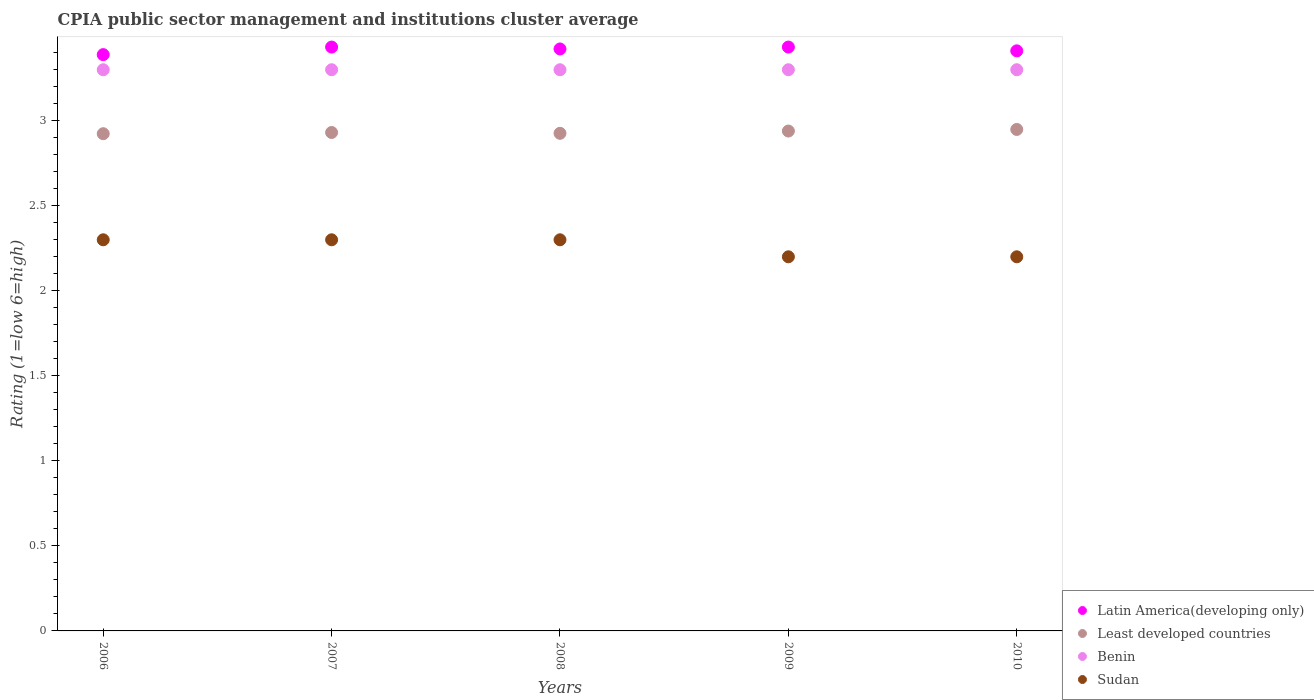What is the CPIA rating in Sudan in 2008?
Provide a short and direct response. 2.3. Across all years, what is the minimum CPIA rating in Benin?
Keep it short and to the point. 3.3. In which year was the CPIA rating in Benin maximum?
Provide a short and direct response. 2006. What is the total CPIA rating in Least developed countries in the graph?
Offer a very short reply. 14.67. What is the difference between the CPIA rating in Least developed countries in 2009 and the CPIA rating in Benin in 2007?
Give a very brief answer. -0.36. What is the average CPIA rating in Benin per year?
Make the answer very short. 3.3. In the year 2009, what is the difference between the CPIA rating in Benin and CPIA rating in Least developed countries?
Provide a short and direct response. 0.36. In how many years, is the CPIA rating in Sudan greater than 3.1?
Make the answer very short. 0. What is the ratio of the CPIA rating in Least developed countries in 2007 to that in 2008?
Your answer should be compact. 1. Is the difference between the CPIA rating in Benin in 2006 and 2007 greater than the difference between the CPIA rating in Least developed countries in 2006 and 2007?
Give a very brief answer. Yes. What is the difference between the highest and the second highest CPIA rating in Least developed countries?
Your response must be concise. 0.01. What is the difference between the highest and the lowest CPIA rating in Latin America(developing only)?
Keep it short and to the point. 0.04. Is it the case that in every year, the sum of the CPIA rating in Sudan and CPIA rating in Least developed countries  is greater than the sum of CPIA rating in Benin and CPIA rating in Latin America(developing only)?
Keep it short and to the point. No. Is it the case that in every year, the sum of the CPIA rating in Latin America(developing only) and CPIA rating in Benin  is greater than the CPIA rating in Sudan?
Ensure brevity in your answer.  Yes. Does the CPIA rating in Latin America(developing only) monotonically increase over the years?
Provide a succinct answer. No. Is the CPIA rating in Latin America(developing only) strictly greater than the CPIA rating in Least developed countries over the years?
Make the answer very short. Yes. How many dotlines are there?
Your answer should be very brief. 4. What is the difference between two consecutive major ticks on the Y-axis?
Give a very brief answer. 0.5. Does the graph contain any zero values?
Ensure brevity in your answer.  No. How are the legend labels stacked?
Offer a very short reply. Vertical. What is the title of the graph?
Your response must be concise. CPIA public sector management and institutions cluster average. Does "Serbia" appear as one of the legend labels in the graph?
Keep it short and to the point. No. What is the Rating (1=low 6=high) in Latin America(developing only) in 2006?
Provide a succinct answer. 3.39. What is the Rating (1=low 6=high) of Least developed countries in 2006?
Provide a succinct answer. 2.92. What is the Rating (1=low 6=high) in Latin America(developing only) in 2007?
Offer a very short reply. 3.43. What is the Rating (1=low 6=high) of Least developed countries in 2007?
Your answer should be very brief. 2.93. What is the Rating (1=low 6=high) in Benin in 2007?
Make the answer very short. 3.3. What is the Rating (1=low 6=high) of Latin America(developing only) in 2008?
Your answer should be very brief. 3.42. What is the Rating (1=low 6=high) in Least developed countries in 2008?
Provide a succinct answer. 2.93. What is the Rating (1=low 6=high) in Sudan in 2008?
Provide a short and direct response. 2.3. What is the Rating (1=low 6=high) of Latin America(developing only) in 2009?
Provide a short and direct response. 3.43. What is the Rating (1=low 6=high) in Least developed countries in 2009?
Offer a terse response. 2.94. What is the Rating (1=low 6=high) of Latin America(developing only) in 2010?
Your response must be concise. 3.41. What is the Rating (1=low 6=high) of Least developed countries in 2010?
Give a very brief answer. 2.95. Across all years, what is the maximum Rating (1=low 6=high) in Latin America(developing only)?
Make the answer very short. 3.43. Across all years, what is the maximum Rating (1=low 6=high) of Least developed countries?
Keep it short and to the point. 2.95. Across all years, what is the maximum Rating (1=low 6=high) of Benin?
Your answer should be compact. 3.3. Across all years, what is the maximum Rating (1=low 6=high) of Sudan?
Provide a succinct answer. 2.3. Across all years, what is the minimum Rating (1=low 6=high) of Latin America(developing only)?
Keep it short and to the point. 3.39. Across all years, what is the minimum Rating (1=low 6=high) in Least developed countries?
Keep it short and to the point. 2.92. Across all years, what is the minimum Rating (1=low 6=high) in Benin?
Provide a short and direct response. 3.3. Across all years, what is the minimum Rating (1=low 6=high) of Sudan?
Offer a very short reply. 2.2. What is the total Rating (1=low 6=high) in Latin America(developing only) in the graph?
Give a very brief answer. 17.09. What is the total Rating (1=low 6=high) of Least developed countries in the graph?
Keep it short and to the point. 14.67. What is the difference between the Rating (1=low 6=high) of Latin America(developing only) in 2006 and that in 2007?
Your response must be concise. -0.04. What is the difference between the Rating (1=low 6=high) of Least developed countries in 2006 and that in 2007?
Provide a succinct answer. -0.01. What is the difference between the Rating (1=low 6=high) of Sudan in 2006 and that in 2007?
Offer a very short reply. 0. What is the difference between the Rating (1=low 6=high) in Latin America(developing only) in 2006 and that in 2008?
Provide a short and direct response. -0.03. What is the difference between the Rating (1=low 6=high) of Least developed countries in 2006 and that in 2008?
Your answer should be very brief. -0. What is the difference between the Rating (1=low 6=high) in Sudan in 2006 and that in 2008?
Keep it short and to the point. 0. What is the difference between the Rating (1=low 6=high) in Latin America(developing only) in 2006 and that in 2009?
Your answer should be very brief. -0.04. What is the difference between the Rating (1=low 6=high) in Least developed countries in 2006 and that in 2009?
Offer a terse response. -0.02. What is the difference between the Rating (1=low 6=high) in Benin in 2006 and that in 2009?
Your answer should be very brief. 0. What is the difference between the Rating (1=low 6=high) in Latin America(developing only) in 2006 and that in 2010?
Provide a succinct answer. -0.02. What is the difference between the Rating (1=low 6=high) in Least developed countries in 2006 and that in 2010?
Your response must be concise. -0.03. What is the difference between the Rating (1=low 6=high) of Benin in 2006 and that in 2010?
Your answer should be very brief. 0. What is the difference between the Rating (1=low 6=high) of Latin America(developing only) in 2007 and that in 2008?
Provide a short and direct response. 0.01. What is the difference between the Rating (1=low 6=high) of Least developed countries in 2007 and that in 2008?
Offer a terse response. 0. What is the difference between the Rating (1=low 6=high) in Least developed countries in 2007 and that in 2009?
Give a very brief answer. -0.01. What is the difference between the Rating (1=low 6=high) in Benin in 2007 and that in 2009?
Your answer should be compact. 0. What is the difference between the Rating (1=low 6=high) of Sudan in 2007 and that in 2009?
Keep it short and to the point. 0.1. What is the difference between the Rating (1=low 6=high) of Latin America(developing only) in 2007 and that in 2010?
Ensure brevity in your answer.  0.02. What is the difference between the Rating (1=low 6=high) of Least developed countries in 2007 and that in 2010?
Offer a terse response. -0.02. What is the difference between the Rating (1=low 6=high) of Latin America(developing only) in 2008 and that in 2009?
Your answer should be very brief. -0.01. What is the difference between the Rating (1=low 6=high) of Least developed countries in 2008 and that in 2009?
Give a very brief answer. -0.01. What is the difference between the Rating (1=low 6=high) of Benin in 2008 and that in 2009?
Your response must be concise. 0. What is the difference between the Rating (1=low 6=high) in Sudan in 2008 and that in 2009?
Give a very brief answer. 0.1. What is the difference between the Rating (1=low 6=high) in Latin America(developing only) in 2008 and that in 2010?
Offer a very short reply. 0.01. What is the difference between the Rating (1=low 6=high) of Least developed countries in 2008 and that in 2010?
Your response must be concise. -0.02. What is the difference between the Rating (1=low 6=high) in Latin America(developing only) in 2009 and that in 2010?
Offer a terse response. 0.02. What is the difference between the Rating (1=low 6=high) of Least developed countries in 2009 and that in 2010?
Ensure brevity in your answer.  -0.01. What is the difference between the Rating (1=low 6=high) in Latin America(developing only) in 2006 and the Rating (1=low 6=high) in Least developed countries in 2007?
Your response must be concise. 0.46. What is the difference between the Rating (1=low 6=high) of Latin America(developing only) in 2006 and the Rating (1=low 6=high) of Benin in 2007?
Offer a terse response. 0.09. What is the difference between the Rating (1=low 6=high) in Latin America(developing only) in 2006 and the Rating (1=low 6=high) in Sudan in 2007?
Provide a succinct answer. 1.09. What is the difference between the Rating (1=low 6=high) in Least developed countries in 2006 and the Rating (1=low 6=high) in Benin in 2007?
Ensure brevity in your answer.  -0.38. What is the difference between the Rating (1=low 6=high) in Least developed countries in 2006 and the Rating (1=low 6=high) in Sudan in 2007?
Make the answer very short. 0.62. What is the difference between the Rating (1=low 6=high) of Latin America(developing only) in 2006 and the Rating (1=low 6=high) of Least developed countries in 2008?
Provide a short and direct response. 0.46. What is the difference between the Rating (1=low 6=high) of Latin America(developing only) in 2006 and the Rating (1=low 6=high) of Benin in 2008?
Offer a terse response. 0.09. What is the difference between the Rating (1=low 6=high) in Latin America(developing only) in 2006 and the Rating (1=low 6=high) in Sudan in 2008?
Ensure brevity in your answer.  1.09. What is the difference between the Rating (1=low 6=high) of Least developed countries in 2006 and the Rating (1=low 6=high) of Benin in 2008?
Offer a very short reply. -0.38. What is the difference between the Rating (1=low 6=high) of Least developed countries in 2006 and the Rating (1=low 6=high) of Sudan in 2008?
Ensure brevity in your answer.  0.62. What is the difference between the Rating (1=low 6=high) of Benin in 2006 and the Rating (1=low 6=high) of Sudan in 2008?
Your answer should be very brief. 1. What is the difference between the Rating (1=low 6=high) of Latin America(developing only) in 2006 and the Rating (1=low 6=high) of Least developed countries in 2009?
Give a very brief answer. 0.45. What is the difference between the Rating (1=low 6=high) of Latin America(developing only) in 2006 and the Rating (1=low 6=high) of Benin in 2009?
Your response must be concise. 0.09. What is the difference between the Rating (1=low 6=high) of Latin America(developing only) in 2006 and the Rating (1=low 6=high) of Sudan in 2009?
Ensure brevity in your answer.  1.19. What is the difference between the Rating (1=low 6=high) of Least developed countries in 2006 and the Rating (1=low 6=high) of Benin in 2009?
Offer a very short reply. -0.38. What is the difference between the Rating (1=low 6=high) of Least developed countries in 2006 and the Rating (1=low 6=high) of Sudan in 2009?
Your answer should be very brief. 0.72. What is the difference between the Rating (1=low 6=high) in Benin in 2006 and the Rating (1=low 6=high) in Sudan in 2009?
Give a very brief answer. 1.1. What is the difference between the Rating (1=low 6=high) in Latin America(developing only) in 2006 and the Rating (1=low 6=high) in Least developed countries in 2010?
Provide a succinct answer. 0.44. What is the difference between the Rating (1=low 6=high) in Latin America(developing only) in 2006 and the Rating (1=low 6=high) in Benin in 2010?
Your answer should be compact. 0.09. What is the difference between the Rating (1=low 6=high) in Latin America(developing only) in 2006 and the Rating (1=low 6=high) in Sudan in 2010?
Your answer should be compact. 1.19. What is the difference between the Rating (1=low 6=high) in Least developed countries in 2006 and the Rating (1=low 6=high) in Benin in 2010?
Provide a short and direct response. -0.38. What is the difference between the Rating (1=low 6=high) in Least developed countries in 2006 and the Rating (1=low 6=high) in Sudan in 2010?
Offer a very short reply. 0.72. What is the difference between the Rating (1=low 6=high) in Benin in 2006 and the Rating (1=low 6=high) in Sudan in 2010?
Make the answer very short. 1.1. What is the difference between the Rating (1=low 6=high) of Latin America(developing only) in 2007 and the Rating (1=low 6=high) of Least developed countries in 2008?
Offer a terse response. 0.51. What is the difference between the Rating (1=low 6=high) in Latin America(developing only) in 2007 and the Rating (1=low 6=high) in Benin in 2008?
Keep it short and to the point. 0.13. What is the difference between the Rating (1=low 6=high) of Latin America(developing only) in 2007 and the Rating (1=low 6=high) of Sudan in 2008?
Give a very brief answer. 1.13. What is the difference between the Rating (1=low 6=high) of Least developed countries in 2007 and the Rating (1=low 6=high) of Benin in 2008?
Make the answer very short. -0.37. What is the difference between the Rating (1=low 6=high) in Least developed countries in 2007 and the Rating (1=low 6=high) in Sudan in 2008?
Your response must be concise. 0.63. What is the difference between the Rating (1=low 6=high) of Latin America(developing only) in 2007 and the Rating (1=low 6=high) of Least developed countries in 2009?
Your response must be concise. 0.49. What is the difference between the Rating (1=low 6=high) in Latin America(developing only) in 2007 and the Rating (1=low 6=high) in Benin in 2009?
Your answer should be very brief. 0.13. What is the difference between the Rating (1=low 6=high) in Latin America(developing only) in 2007 and the Rating (1=low 6=high) in Sudan in 2009?
Give a very brief answer. 1.23. What is the difference between the Rating (1=low 6=high) in Least developed countries in 2007 and the Rating (1=low 6=high) in Benin in 2009?
Your answer should be compact. -0.37. What is the difference between the Rating (1=low 6=high) of Least developed countries in 2007 and the Rating (1=low 6=high) of Sudan in 2009?
Your answer should be compact. 0.73. What is the difference between the Rating (1=low 6=high) in Latin America(developing only) in 2007 and the Rating (1=low 6=high) in Least developed countries in 2010?
Offer a terse response. 0.48. What is the difference between the Rating (1=low 6=high) in Latin America(developing only) in 2007 and the Rating (1=low 6=high) in Benin in 2010?
Your answer should be compact. 0.13. What is the difference between the Rating (1=low 6=high) in Latin America(developing only) in 2007 and the Rating (1=low 6=high) in Sudan in 2010?
Provide a short and direct response. 1.23. What is the difference between the Rating (1=low 6=high) in Least developed countries in 2007 and the Rating (1=low 6=high) in Benin in 2010?
Your response must be concise. -0.37. What is the difference between the Rating (1=low 6=high) in Least developed countries in 2007 and the Rating (1=low 6=high) in Sudan in 2010?
Offer a very short reply. 0.73. What is the difference between the Rating (1=low 6=high) of Latin America(developing only) in 2008 and the Rating (1=low 6=high) of Least developed countries in 2009?
Provide a succinct answer. 0.48. What is the difference between the Rating (1=low 6=high) of Latin America(developing only) in 2008 and the Rating (1=low 6=high) of Benin in 2009?
Offer a very short reply. 0.12. What is the difference between the Rating (1=low 6=high) in Latin America(developing only) in 2008 and the Rating (1=low 6=high) in Sudan in 2009?
Your answer should be compact. 1.22. What is the difference between the Rating (1=low 6=high) in Least developed countries in 2008 and the Rating (1=low 6=high) in Benin in 2009?
Your response must be concise. -0.37. What is the difference between the Rating (1=low 6=high) of Least developed countries in 2008 and the Rating (1=low 6=high) of Sudan in 2009?
Provide a succinct answer. 0.73. What is the difference between the Rating (1=low 6=high) of Benin in 2008 and the Rating (1=low 6=high) of Sudan in 2009?
Ensure brevity in your answer.  1.1. What is the difference between the Rating (1=low 6=high) of Latin America(developing only) in 2008 and the Rating (1=low 6=high) of Least developed countries in 2010?
Offer a very short reply. 0.47. What is the difference between the Rating (1=low 6=high) of Latin America(developing only) in 2008 and the Rating (1=low 6=high) of Benin in 2010?
Give a very brief answer. 0.12. What is the difference between the Rating (1=low 6=high) of Latin America(developing only) in 2008 and the Rating (1=low 6=high) of Sudan in 2010?
Give a very brief answer. 1.22. What is the difference between the Rating (1=low 6=high) in Least developed countries in 2008 and the Rating (1=low 6=high) in Benin in 2010?
Offer a very short reply. -0.37. What is the difference between the Rating (1=low 6=high) of Least developed countries in 2008 and the Rating (1=low 6=high) of Sudan in 2010?
Your answer should be compact. 0.73. What is the difference between the Rating (1=low 6=high) in Benin in 2008 and the Rating (1=low 6=high) in Sudan in 2010?
Your response must be concise. 1.1. What is the difference between the Rating (1=low 6=high) in Latin America(developing only) in 2009 and the Rating (1=low 6=high) in Least developed countries in 2010?
Offer a very short reply. 0.48. What is the difference between the Rating (1=low 6=high) of Latin America(developing only) in 2009 and the Rating (1=low 6=high) of Benin in 2010?
Offer a terse response. 0.13. What is the difference between the Rating (1=low 6=high) in Latin America(developing only) in 2009 and the Rating (1=low 6=high) in Sudan in 2010?
Your answer should be compact. 1.23. What is the difference between the Rating (1=low 6=high) in Least developed countries in 2009 and the Rating (1=low 6=high) in Benin in 2010?
Give a very brief answer. -0.36. What is the difference between the Rating (1=low 6=high) of Least developed countries in 2009 and the Rating (1=low 6=high) of Sudan in 2010?
Provide a short and direct response. 0.74. What is the difference between the Rating (1=low 6=high) of Benin in 2009 and the Rating (1=low 6=high) of Sudan in 2010?
Make the answer very short. 1.1. What is the average Rating (1=low 6=high) of Latin America(developing only) per year?
Offer a very short reply. 3.42. What is the average Rating (1=low 6=high) of Least developed countries per year?
Your answer should be compact. 2.93. What is the average Rating (1=low 6=high) in Benin per year?
Give a very brief answer. 3.3. What is the average Rating (1=low 6=high) in Sudan per year?
Your response must be concise. 2.26. In the year 2006, what is the difference between the Rating (1=low 6=high) of Latin America(developing only) and Rating (1=low 6=high) of Least developed countries?
Your response must be concise. 0.47. In the year 2006, what is the difference between the Rating (1=low 6=high) of Latin America(developing only) and Rating (1=low 6=high) of Benin?
Keep it short and to the point. 0.09. In the year 2006, what is the difference between the Rating (1=low 6=high) in Latin America(developing only) and Rating (1=low 6=high) in Sudan?
Offer a very short reply. 1.09. In the year 2006, what is the difference between the Rating (1=low 6=high) in Least developed countries and Rating (1=low 6=high) in Benin?
Provide a short and direct response. -0.38. In the year 2006, what is the difference between the Rating (1=low 6=high) of Least developed countries and Rating (1=low 6=high) of Sudan?
Ensure brevity in your answer.  0.62. In the year 2006, what is the difference between the Rating (1=low 6=high) in Benin and Rating (1=low 6=high) in Sudan?
Make the answer very short. 1. In the year 2007, what is the difference between the Rating (1=low 6=high) of Latin America(developing only) and Rating (1=low 6=high) of Least developed countries?
Make the answer very short. 0.5. In the year 2007, what is the difference between the Rating (1=low 6=high) of Latin America(developing only) and Rating (1=low 6=high) of Benin?
Provide a short and direct response. 0.13. In the year 2007, what is the difference between the Rating (1=low 6=high) of Latin America(developing only) and Rating (1=low 6=high) of Sudan?
Offer a terse response. 1.13. In the year 2007, what is the difference between the Rating (1=low 6=high) of Least developed countries and Rating (1=low 6=high) of Benin?
Ensure brevity in your answer.  -0.37. In the year 2007, what is the difference between the Rating (1=low 6=high) of Least developed countries and Rating (1=low 6=high) of Sudan?
Your answer should be very brief. 0.63. In the year 2007, what is the difference between the Rating (1=low 6=high) of Benin and Rating (1=low 6=high) of Sudan?
Ensure brevity in your answer.  1. In the year 2008, what is the difference between the Rating (1=low 6=high) in Latin America(developing only) and Rating (1=low 6=high) in Least developed countries?
Give a very brief answer. 0.5. In the year 2008, what is the difference between the Rating (1=low 6=high) of Latin America(developing only) and Rating (1=low 6=high) of Benin?
Your answer should be very brief. 0.12. In the year 2008, what is the difference between the Rating (1=low 6=high) in Latin America(developing only) and Rating (1=low 6=high) in Sudan?
Offer a terse response. 1.12. In the year 2008, what is the difference between the Rating (1=low 6=high) in Least developed countries and Rating (1=low 6=high) in Benin?
Give a very brief answer. -0.37. In the year 2008, what is the difference between the Rating (1=low 6=high) in Least developed countries and Rating (1=low 6=high) in Sudan?
Offer a terse response. 0.63. In the year 2008, what is the difference between the Rating (1=low 6=high) in Benin and Rating (1=low 6=high) in Sudan?
Offer a terse response. 1. In the year 2009, what is the difference between the Rating (1=low 6=high) in Latin America(developing only) and Rating (1=low 6=high) in Least developed countries?
Your answer should be very brief. 0.49. In the year 2009, what is the difference between the Rating (1=low 6=high) of Latin America(developing only) and Rating (1=low 6=high) of Benin?
Your answer should be compact. 0.13. In the year 2009, what is the difference between the Rating (1=low 6=high) of Latin America(developing only) and Rating (1=low 6=high) of Sudan?
Offer a very short reply. 1.23. In the year 2009, what is the difference between the Rating (1=low 6=high) in Least developed countries and Rating (1=low 6=high) in Benin?
Provide a succinct answer. -0.36. In the year 2009, what is the difference between the Rating (1=low 6=high) of Least developed countries and Rating (1=low 6=high) of Sudan?
Your answer should be compact. 0.74. In the year 2010, what is the difference between the Rating (1=low 6=high) in Latin America(developing only) and Rating (1=low 6=high) in Least developed countries?
Give a very brief answer. 0.46. In the year 2010, what is the difference between the Rating (1=low 6=high) in Latin America(developing only) and Rating (1=low 6=high) in Benin?
Offer a very short reply. 0.11. In the year 2010, what is the difference between the Rating (1=low 6=high) of Latin America(developing only) and Rating (1=low 6=high) of Sudan?
Offer a very short reply. 1.21. In the year 2010, what is the difference between the Rating (1=low 6=high) in Least developed countries and Rating (1=low 6=high) in Benin?
Make the answer very short. -0.35. In the year 2010, what is the difference between the Rating (1=low 6=high) in Least developed countries and Rating (1=low 6=high) in Sudan?
Offer a very short reply. 0.75. In the year 2010, what is the difference between the Rating (1=low 6=high) of Benin and Rating (1=low 6=high) of Sudan?
Provide a short and direct response. 1.1. What is the ratio of the Rating (1=low 6=high) in Latin America(developing only) in 2006 to that in 2007?
Provide a short and direct response. 0.99. What is the ratio of the Rating (1=low 6=high) of Sudan in 2006 to that in 2007?
Keep it short and to the point. 1. What is the ratio of the Rating (1=low 6=high) of Latin America(developing only) in 2006 to that in 2008?
Your answer should be compact. 0.99. What is the ratio of the Rating (1=low 6=high) of Least developed countries in 2006 to that in 2008?
Give a very brief answer. 1. What is the ratio of the Rating (1=low 6=high) in Sudan in 2006 to that in 2008?
Your response must be concise. 1. What is the ratio of the Rating (1=low 6=high) in Latin America(developing only) in 2006 to that in 2009?
Offer a terse response. 0.99. What is the ratio of the Rating (1=low 6=high) in Least developed countries in 2006 to that in 2009?
Give a very brief answer. 0.99. What is the ratio of the Rating (1=low 6=high) in Benin in 2006 to that in 2009?
Offer a very short reply. 1. What is the ratio of the Rating (1=low 6=high) of Sudan in 2006 to that in 2009?
Offer a very short reply. 1.05. What is the ratio of the Rating (1=low 6=high) in Latin America(developing only) in 2006 to that in 2010?
Your response must be concise. 0.99. What is the ratio of the Rating (1=low 6=high) in Least developed countries in 2006 to that in 2010?
Your answer should be compact. 0.99. What is the ratio of the Rating (1=low 6=high) in Sudan in 2006 to that in 2010?
Keep it short and to the point. 1.05. What is the ratio of the Rating (1=low 6=high) in Sudan in 2007 to that in 2008?
Ensure brevity in your answer.  1. What is the ratio of the Rating (1=low 6=high) in Least developed countries in 2007 to that in 2009?
Your answer should be very brief. 1. What is the ratio of the Rating (1=low 6=high) in Benin in 2007 to that in 2009?
Give a very brief answer. 1. What is the ratio of the Rating (1=low 6=high) in Sudan in 2007 to that in 2009?
Keep it short and to the point. 1.05. What is the ratio of the Rating (1=low 6=high) of Least developed countries in 2007 to that in 2010?
Provide a short and direct response. 0.99. What is the ratio of the Rating (1=low 6=high) of Sudan in 2007 to that in 2010?
Your answer should be compact. 1.05. What is the ratio of the Rating (1=low 6=high) in Least developed countries in 2008 to that in 2009?
Keep it short and to the point. 1. What is the ratio of the Rating (1=low 6=high) of Benin in 2008 to that in 2009?
Your response must be concise. 1. What is the ratio of the Rating (1=low 6=high) in Sudan in 2008 to that in 2009?
Keep it short and to the point. 1.05. What is the ratio of the Rating (1=low 6=high) in Latin America(developing only) in 2008 to that in 2010?
Your response must be concise. 1. What is the ratio of the Rating (1=low 6=high) in Least developed countries in 2008 to that in 2010?
Keep it short and to the point. 0.99. What is the ratio of the Rating (1=low 6=high) of Benin in 2008 to that in 2010?
Your response must be concise. 1. What is the ratio of the Rating (1=low 6=high) of Sudan in 2008 to that in 2010?
Offer a terse response. 1.05. What is the ratio of the Rating (1=low 6=high) in Sudan in 2009 to that in 2010?
Give a very brief answer. 1. What is the difference between the highest and the second highest Rating (1=low 6=high) of Least developed countries?
Provide a short and direct response. 0.01. What is the difference between the highest and the second highest Rating (1=low 6=high) of Benin?
Make the answer very short. 0. What is the difference between the highest and the second highest Rating (1=low 6=high) of Sudan?
Make the answer very short. 0. What is the difference between the highest and the lowest Rating (1=low 6=high) of Latin America(developing only)?
Keep it short and to the point. 0.04. What is the difference between the highest and the lowest Rating (1=low 6=high) of Least developed countries?
Give a very brief answer. 0.03. What is the difference between the highest and the lowest Rating (1=low 6=high) of Benin?
Keep it short and to the point. 0. What is the difference between the highest and the lowest Rating (1=low 6=high) of Sudan?
Provide a succinct answer. 0.1. 